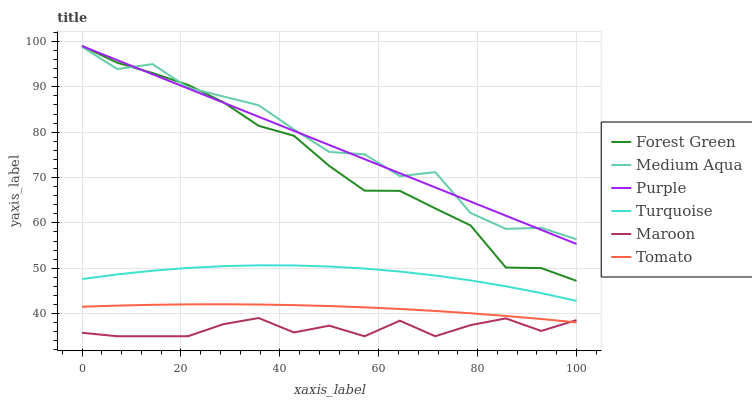Does Maroon have the minimum area under the curve?
Answer yes or no. Yes. Does Medium Aqua have the maximum area under the curve?
Answer yes or no. Yes. Does Turquoise have the minimum area under the curve?
Answer yes or no. No. Does Turquoise have the maximum area under the curve?
Answer yes or no. No. Is Purple the smoothest?
Answer yes or no. Yes. Is Medium Aqua the roughest?
Answer yes or no. Yes. Is Turquoise the smoothest?
Answer yes or no. No. Is Turquoise the roughest?
Answer yes or no. No. Does Maroon have the lowest value?
Answer yes or no. Yes. Does Turquoise have the lowest value?
Answer yes or no. No. Does Forest Green have the highest value?
Answer yes or no. Yes. Does Turquoise have the highest value?
Answer yes or no. No. Is Maroon less than Turquoise?
Answer yes or no. Yes. Is Forest Green greater than Tomato?
Answer yes or no. Yes. Does Medium Aqua intersect Forest Green?
Answer yes or no. Yes. Is Medium Aqua less than Forest Green?
Answer yes or no. No. Is Medium Aqua greater than Forest Green?
Answer yes or no. No. Does Maroon intersect Turquoise?
Answer yes or no. No. 